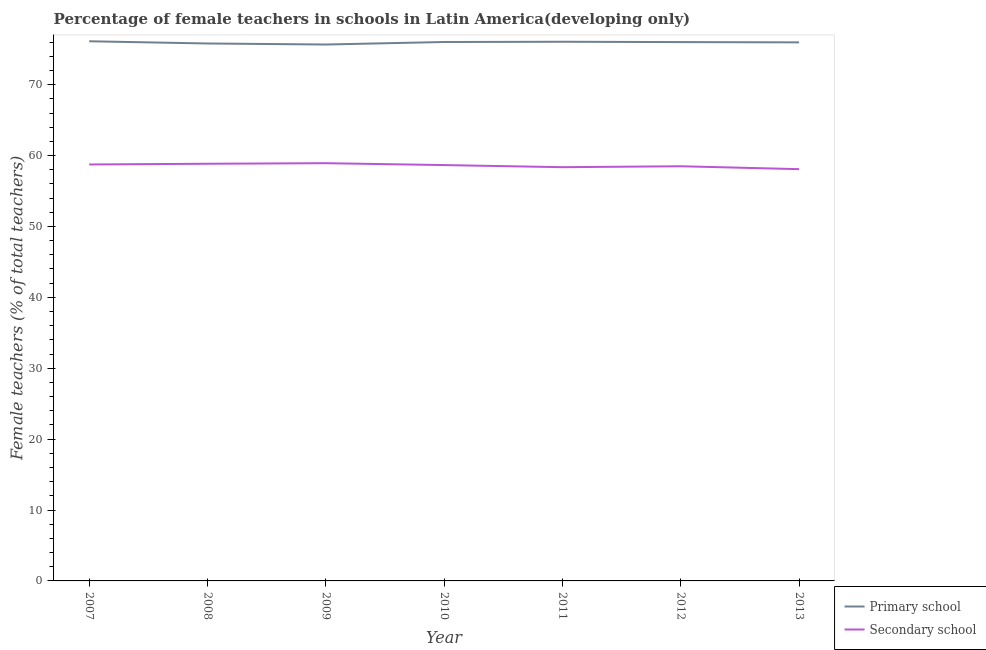Does the line corresponding to percentage of female teachers in secondary schools intersect with the line corresponding to percentage of female teachers in primary schools?
Provide a short and direct response. No. What is the percentage of female teachers in secondary schools in 2011?
Offer a terse response. 58.36. Across all years, what is the maximum percentage of female teachers in secondary schools?
Offer a terse response. 58.92. Across all years, what is the minimum percentage of female teachers in primary schools?
Offer a terse response. 75.66. In which year was the percentage of female teachers in primary schools minimum?
Provide a succinct answer. 2009. What is the total percentage of female teachers in secondary schools in the graph?
Offer a terse response. 410.08. What is the difference between the percentage of female teachers in primary schools in 2007 and that in 2008?
Your answer should be compact. 0.31. What is the difference between the percentage of female teachers in secondary schools in 2009 and the percentage of female teachers in primary schools in 2012?
Keep it short and to the point. -17.08. What is the average percentage of female teachers in primary schools per year?
Your answer should be very brief. 75.94. In the year 2010, what is the difference between the percentage of female teachers in secondary schools and percentage of female teachers in primary schools?
Make the answer very short. -17.36. What is the ratio of the percentage of female teachers in primary schools in 2008 to that in 2010?
Offer a very short reply. 1. Is the percentage of female teachers in secondary schools in 2011 less than that in 2013?
Offer a terse response. No. What is the difference between the highest and the second highest percentage of female teachers in secondary schools?
Your response must be concise. 0.08. What is the difference between the highest and the lowest percentage of female teachers in primary schools?
Your answer should be very brief. 0.46. Does the graph contain any zero values?
Offer a very short reply. No. Does the graph contain grids?
Your answer should be very brief. No. Where does the legend appear in the graph?
Provide a succinct answer. Bottom right. How many legend labels are there?
Ensure brevity in your answer.  2. How are the legend labels stacked?
Make the answer very short. Vertical. What is the title of the graph?
Offer a very short reply. Percentage of female teachers in schools in Latin America(developing only). Does "Gasoline" appear as one of the legend labels in the graph?
Provide a succinct answer. No. What is the label or title of the X-axis?
Offer a very short reply. Year. What is the label or title of the Y-axis?
Give a very brief answer. Female teachers (% of total teachers). What is the Female teachers (% of total teachers) in Primary school in 2007?
Make the answer very short. 76.12. What is the Female teachers (% of total teachers) of Secondary school in 2007?
Offer a very short reply. 58.74. What is the Female teachers (% of total teachers) in Primary school in 2008?
Make the answer very short. 75.81. What is the Female teachers (% of total teachers) of Secondary school in 2008?
Offer a very short reply. 58.84. What is the Female teachers (% of total teachers) of Primary school in 2009?
Your answer should be compact. 75.66. What is the Female teachers (% of total teachers) in Secondary school in 2009?
Provide a short and direct response. 58.92. What is the Female teachers (% of total teachers) of Primary school in 2010?
Your response must be concise. 76.02. What is the Female teachers (% of total teachers) of Secondary school in 2010?
Your response must be concise. 58.65. What is the Female teachers (% of total teachers) of Primary school in 2011?
Ensure brevity in your answer.  76.05. What is the Female teachers (% of total teachers) in Secondary school in 2011?
Your response must be concise. 58.36. What is the Female teachers (% of total teachers) of Primary school in 2012?
Give a very brief answer. 76. What is the Female teachers (% of total teachers) in Secondary school in 2012?
Your answer should be compact. 58.49. What is the Female teachers (% of total teachers) in Primary school in 2013?
Keep it short and to the point. 75.96. What is the Female teachers (% of total teachers) in Secondary school in 2013?
Offer a terse response. 58.08. Across all years, what is the maximum Female teachers (% of total teachers) in Primary school?
Give a very brief answer. 76.12. Across all years, what is the maximum Female teachers (% of total teachers) in Secondary school?
Make the answer very short. 58.92. Across all years, what is the minimum Female teachers (% of total teachers) of Primary school?
Provide a succinct answer. 75.66. Across all years, what is the minimum Female teachers (% of total teachers) in Secondary school?
Provide a short and direct response. 58.08. What is the total Female teachers (% of total teachers) of Primary school in the graph?
Provide a succinct answer. 531.61. What is the total Female teachers (% of total teachers) of Secondary school in the graph?
Make the answer very short. 410.08. What is the difference between the Female teachers (% of total teachers) of Primary school in 2007 and that in 2008?
Give a very brief answer. 0.31. What is the difference between the Female teachers (% of total teachers) in Secondary school in 2007 and that in 2008?
Make the answer very short. -0.1. What is the difference between the Female teachers (% of total teachers) of Primary school in 2007 and that in 2009?
Ensure brevity in your answer.  0.46. What is the difference between the Female teachers (% of total teachers) of Secondary school in 2007 and that in 2009?
Provide a short and direct response. -0.18. What is the difference between the Female teachers (% of total teachers) in Primary school in 2007 and that in 2010?
Your answer should be very brief. 0.1. What is the difference between the Female teachers (% of total teachers) in Secondary school in 2007 and that in 2010?
Ensure brevity in your answer.  0.09. What is the difference between the Female teachers (% of total teachers) of Primary school in 2007 and that in 2011?
Give a very brief answer. 0.07. What is the difference between the Female teachers (% of total teachers) of Secondary school in 2007 and that in 2011?
Offer a terse response. 0.38. What is the difference between the Female teachers (% of total teachers) in Primary school in 2007 and that in 2012?
Keep it short and to the point. 0.12. What is the difference between the Female teachers (% of total teachers) in Secondary school in 2007 and that in 2012?
Your response must be concise. 0.25. What is the difference between the Female teachers (% of total teachers) of Primary school in 2007 and that in 2013?
Offer a terse response. 0.15. What is the difference between the Female teachers (% of total teachers) of Secondary school in 2007 and that in 2013?
Make the answer very short. 0.66. What is the difference between the Female teachers (% of total teachers) in Primary school in 2008 and that in 2009?
Make the answer very short. 0.15. What is the difference between the Female teachers (% of total teachers) in Secondary school in 2008 and that in 2009?
Offer a very short reply. -0.08. What is the difference between the Female teachers (% of total teachers) in Primary school in 2008 and that in 2010?
Provide a short and direct response. -0.21. What is the difference between the Female teachers (% of total teachers) of Secondary school in 2008 and that in 2010?
Your answer should be very brief. 0.19. What is the difference between the Female teachers (% of total teachers) in Primary school in 2008 and that in 2011?
Make the answer very short. -0.24. What is the difference between the Female teachers (% of total teachers) of Secondary school in 2008 and that in 2011?
Offer a very short reply. 0.49. What is the difference between the Female teachers (% of total teachers) of Primary school in 2008 and that in 2012?
Offer a very short reply. -0.19. What is the difference between the Female teachers (% of total teachers) in Secondary school in 2008 and that in 2012?
Give a very brief answer. 0.35. What is the difference between the Female teachers (% of total teachers) in Primary school in 2008 and that in 2013?
Ensure brevity in your answer.  -0.16. What is the difference between the Female teachers (% of total teachers) in Secondary school in 2008 and that in 2013?
Your response must be concise. 0.76. What is the difference between the Female teachers (% of total teachers) of Primary school in 2009 and that in 2010?
Provide a short and direct response. -0.36. What is the difference between the Female teachers (% of total teachers) in Secondary school in 2009 and that in 2010?
Your answer should be very brief. 0.27. What is the difference between the Female teachers (% of total teachers) of Primary school in 2009 and that in 2011?
Offer a terse response. -0.39. What is the difference between the Female teachers (% of total teachers) in Secondary school in 2009 and that in 2011?
Your answer should be very brief. 0.57. What is the difference between the Female teachers (% of total teachers) in Primary school in 2009 and that in 2012?
Make the answer very short. -0.34. What is the difference between the Female teachers (% of total teachers) of Secondary school in 2009 and that in 2012?
Your answer should be compact. 0.43. What is the difference between the Female teachers (% of total teachers) of Primary school in 2009 and that in 2013?
Ensure brevity in your answer.  -0.3. What is the difference between the Female teachers (% of total teachers) in Secondary school in 2009 and that in 2013?
Provide a short and direct response. 0.84. What is the difference between the Female teachers (% of total teachers) of Primary school in 2010 and that in 2011?
Keep it short and to the point. -0.03. What is the difference between the Female teachers (% of total teachers) in Secondary school in 2010 and that in 2011?
Ensure brevity in your answer.  0.3. What is the difference between the Female teachers (% of total teachers) in Primary school in 2010 and that in 2012?
Your answer should be compact. 0.01. What is the difference between the Female teachers (% of total teachers) in Secondary school in 2010 and that in 2012?
Give a very brief answer. 0.16. What is the difference between the Female teachers (% of total teachers) in Primary school in 2010 and that in 2013?
Provide a succinct answer. 0.05. What is the difference between the Female teachers (% of total teachers) of Secondary school in 2010 and that in 2013?
Offer a terse response. 0.58. What is the difference between the Female teachers (% of total teachers) of Primary school in 2011 and that in 2012?
Your answer should be compact. 0.05. What is the difference between the Female teachers (% of total teachers) in Secondary school in 2011 and that in 2012?
Keep it short and to the point. -0.13. What is the difference between the Female teachers (% of total teachers) in Primary school in 2011 and that in 2013?
Your answer should be compact. 0.09. What is the difference between the Female teachers (% of total teachers) of Secondary school in 2011 and that in 2013?
Keep it short and to the point. 0.28. What is the difference between the Female teachers (% of total teachers) of Primary school in 2012 and that in 2013?
Your answer should be compact. 0.04. What is the difference between the Female teachers (% of total teachers) in Secondary school in 2012 and that in 2013?
Your answer should be compact. 0.41. What is the difference between the Female teachers (% of total teachers) of Primary school in 2007 and the Female teachers (% of total teachers) of Secondary school in 2008?
Your answer should be compact. 17.28. What is the difference between the Female teachers (% of total teachers) in Primary school in 2007 and the Female teachers (% of total teachers) in Secondary school in 2009?
Offer a terse response. 17.2. What is the difference between the Female teachers (% of total teachers) in Primary school in 2007 and the Female teachers (% of total teachers) in Secondary school in 2010?
Keep it short and to the point. 17.46. What is the difference between the Female teachers (% of total teachers) in Primary school in 2007 and the Female teachers (% of total teachers) in Secondary school in 2011?
Offer a terse response. 17.76. What is the difference between the Female teachers (% of total teachers) of Primary school in 2007 and the Female teachers (% of total teachers) of Secondary school in 2012?
Your response must be concise. 17.63. What is the difference between the Female teachers (% of total teachers) in Primary school in 2007 and the Female teachers (% of total teachers) in Secondary school in 2013?
Provide a succinct answer. 18.04. What is the difference between the Female teachers (% of total teachers) of Primary school in 2008 and the Female teachers (% of total teachers) of Secondary school in 2009?
Keep it short and to the point. 16.88. What is the difference between the Female teachers (% of total teachers) in Primary school in 2008 and the Female teachers (% of total teachers) in Secondary school in 2010?
Offer a terse response. 17.15. What is the difference between the Female teachers (% of total teachers) in Primary school in 2008 and the Female teachers (% of total teachers) in Secondary school in 2011?
Keep it short and to the point. 17.45. What is the difference between the Female teachers (% of total teachers) in Primary school in 2008 and the Female teachers (% of total teachers) in Secondary school in 2012?
Make the answer very short. 17.32. What is the difference between the Female teachers (% of total teachers) in Primary school in 2008 and the Female teachers (% of total teachers) in Secondary school in 2013?
Your response must be concise. 17.73. What is the difference between the Female teachers (% of total teachers) of Primary school in 2009 and the Female teachers (% of total teachers) of Secondary school in 2010?
Your answer should be very brief. 17.01. What is the difference between the Female teachers (% of total teachers) of Primary school in 2009 and the Female teachers (% of total teachers) of Secondary school in 2011?
Your answer should be compact. 17.3. What is the difference between the Female teachers (% of total teachers) in Primary school in 2009 and the Female teachers (% of total teachers) in Secondary school in 2012?
Provide a short and direct response. 17.17. What is the difference between the Female teachers (% of total teachers) of Primary school in 2009 and the Female teachers (% of total teachers) of Secondary school in 2013?
Your response must be concise. 17.58. What is the difference between the Female teachers (% of total teachers) in Primary school in 2010 and the Female teachers (% of total teachers) in Secondary school in 2011?
Make the answer very short. 17.66. What is the difference between the Female teachers (% of total teachers) in Primary school in 2010 and the Female teachers (% of total teachers) in Secondary school in 2012?
Ensure brevity in your answer.  17.53. What is the difference between the Female teachers (% of total teachers) in Primary school in 2010 and the Female teachers (% of total teachers) in Secondary school in 2013?
Your response must be concise. 17.94. What is the difference between the Female teachers (% of total teachers) in Primary school in 2011 and the Female teachers (% of total teachers) in Secondary school in 2012?
Make the answer very short. 17.56. What is the difference between the Female teachers (% of total teachers) in Primary school in 2011 and the Female teachers (% of total teachers) in Secondary school in 2013?
Your answer should be compact. 17.97. What is the difference between the Female teachers (% of total teachers) of Primary school in 2012 and the Female teachers (% of total teachers) of Secondary school in 2013?
Ensure brevity in your answer.  17.92. What is the average Female teachers (% of total teachers) in Primary school per year?
Make the answer very short. 75.94. What is the average Female teachers (% of total teachers) in Secondary school per year?
Ensure brevity in your answer.  58.58. In the year 2007, what is the difference between the Female teachers (% of total teachers) in Primary school and Female teachers (% of total teachers) in Secondary school?
Give a very brief answer. 17.38. In the year 2008, what is the difference between the Female teachers (% of total teachers) in Primary school and Female teachers (% of total teachers) in Secondary school?
Ensure brevity in your answer.  16.96. In the year 2009, what is the difference between the Female teachers (% of total teachers) of Primary school and Female teachers (% of total teachers) of Secondary school?
Your response must be concise. 16.74. In the year 2010, what is the difference between the Female teachers (% of total teachers) of Primary school and Female teachers (% of total teachers) of Secondary school?
Ensure brevity in your answer.  17.36. In the year 2011, what is the difference between the Female teachers (% of total teachers) of Primary school and Female teachers (% of total teachers) of Secondary school?
Your response must be concise. 17.69. In the year 2012, what is the difference between the Female teachers (% of total teachers) of Primary school and Female teachers (% of total teachers) of Secondary school?
Provide a short and direct response. 17.51. In the year 2013, what is the difference between the Female teachers (% of total teachers) in Primary school and Female teachers (% of total teachers) in Secondary school?
Your answer should be compact. 17.88. What is the ratio of the Female teachers (% of total teachers) of Primary school in 2007 to that in 2009?
Offer a terse response. 1.01. What is the ratio of the Female teachers (% of total teachers) in Secondary school in 2007 to that in 2010?
Offer a terse response. 1. What is the ratio of the Female teachers (% of total teachers) of Primary school in 2007 to that in 2011?
Your answer should be compact. 1. What is the ratio of the Female teachers (% of total teachers) of Secondary school in 2007 to that in 2011?
Ensure brevity in your answer.  1.01. What is the ratio of the Female teachers (% of total teachers) of Secondary school in 2007 to that in 2012?
Offer a very short reply. 1. What is the ratio of the Female teachers (% of total teachers) of Secondary school in 2007 to that in 2013?
Offer a terse response. 1.01. What is the ratio of the Female teachers (% of total teachers) of Primary school in 2008 to that in 2010?
Your response must be concise. 1. What is the ratio of the Female teachers (% of total teachers) of Secondary school in 2008 to that in 2011?
Give a very brief answer. 1.01. What is the ratio of the Female teachers (% of total teachers) of Primary school in 2008 to that in 2012?
Offer a terse response. 1. What is the ratio of the Female teachers (% of total teachers) in Secondary school in 2008 to that in 2012?
Provide a short and direct response. 1.01. What is the ratio of the Female teachers (% of total teachers) of Primary school in 2008 to that in 2013?
Ensure brevity in your answer.  1. What is the ratio of the Female teachers (% of total teachers) in Secondary school in 2008 to that in 2013?
Your answer should be very brief. 1.01. What is the ratio of the Female teachers (% of total teachers) in Secondary school in 2009 to that in 2011?
Provide a succinct answer. 1.01. What is the ratio of the Female teachers (% of total teachers) of Secondary school in 2009 to that in 2012?
Keep it short and to the point. 1.01. What is the ratio of the Female teachers (% of total teachers) in Secondary school in 2009 to that in 2013?
Give a very brief answer. 1.01. What is the ratio of the Female teachers (% of total teachers) in Primary school in 2010 to that in 2012?
Make the answer very short. 1. What is the ratio of the Female teachers (% of total teachers) of Secondary school in 2010 to that in 2012?
Give a very brief answer. 1. What is the ratio of the Female teachers (% of total teachers) of Primary school in 2010 to that in 2013?
Your answer should be very brief. 1. What is the ratio of the Female teachers (% of total teachers) in Secondary school in 2010 to that in 2013?
Your answer should be very brief. 1.01. What is the ratio of the Female teachers (% of total teachers) of Primary school in 2011 to that in 2013?
Provide a short and direct response. 1. What is the ratio of the Female teachers (% of total teachers) in Secondary school in 2011 to that in 2013?
Your answer should be compact. 1. What is the ratio of the Female teachers (% of total teachers) of Primary school in 2012 to that in 2013?
Ensure brevity in your answer.  1. What is the ratio of the Female teachers (% of total teachers) of Secondary school in 2012 to that in 2013?
Offer a very short reply. 1.01. What is the difference between the highest and the second highest Female teachers (% of total teachers) in Primary school?
Your answer should be very brief. 0.07. What is the difference between the highest and the second highest Female teachers (% of total teachers) in Secondary school?
Make the answer very short. 0.08. What is the difference between the highest and the lowest Female teachers (% of total teachers) in Primary school?
Make the answer very short. 0.46. What is the difference between the highest and the lowest Female teachers (% of total teachers) in Secondary school?
Your response must be concise. 0.84. 